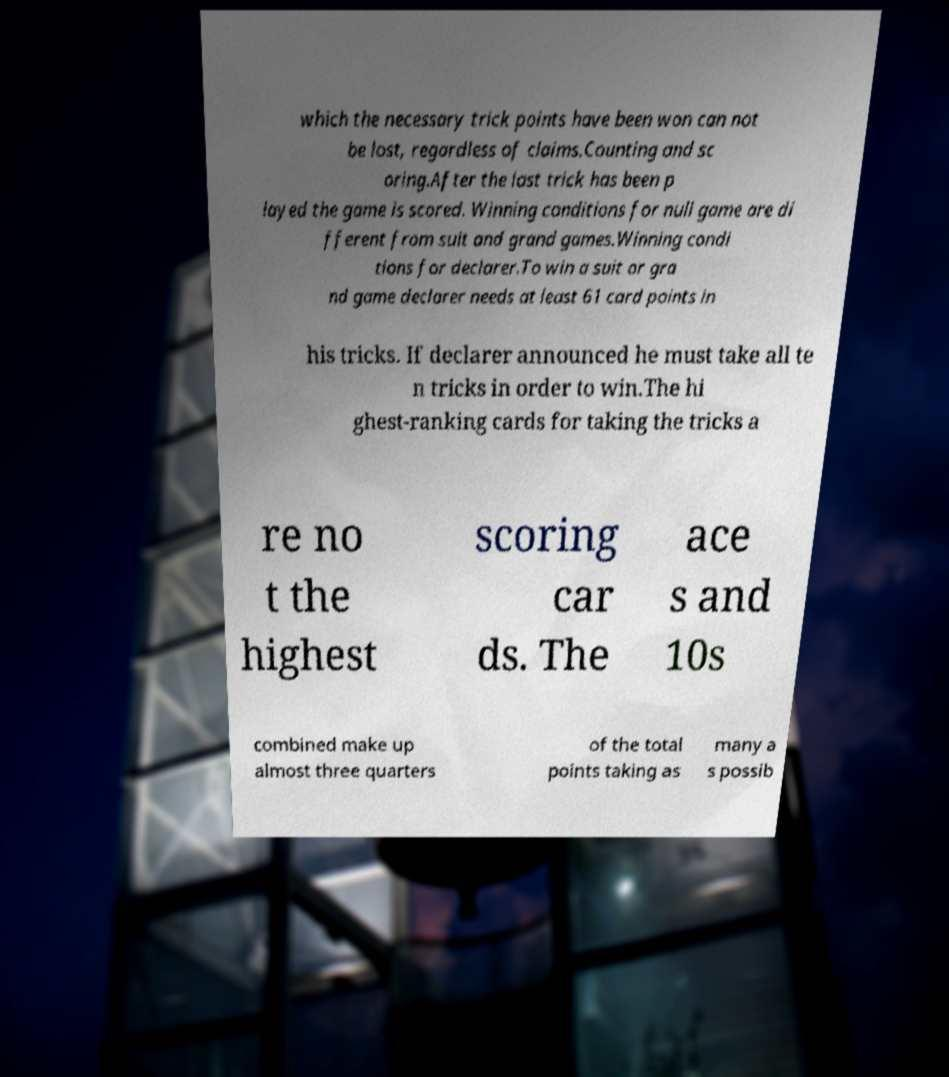Please identify and transcribe the text found in this image. which the necessary trick points have been won can not be lost, regardless of claims.Counting and sc oring.After the last trick has been p layed the game is scored. Winning conditions for null game are di fferent from suit and grand games.Winning condi tions for declarer.To win a suit or gra nd game declarer needs at least 61 card points in his tricks. If declarer announced he must take all te n tricks in order to win.The hi ghest-ranking cards for taking the tricks a re no t the highest scoring car ds. The ace s and 10s combined make up almost three quarters of the total points taking as many a s possib 